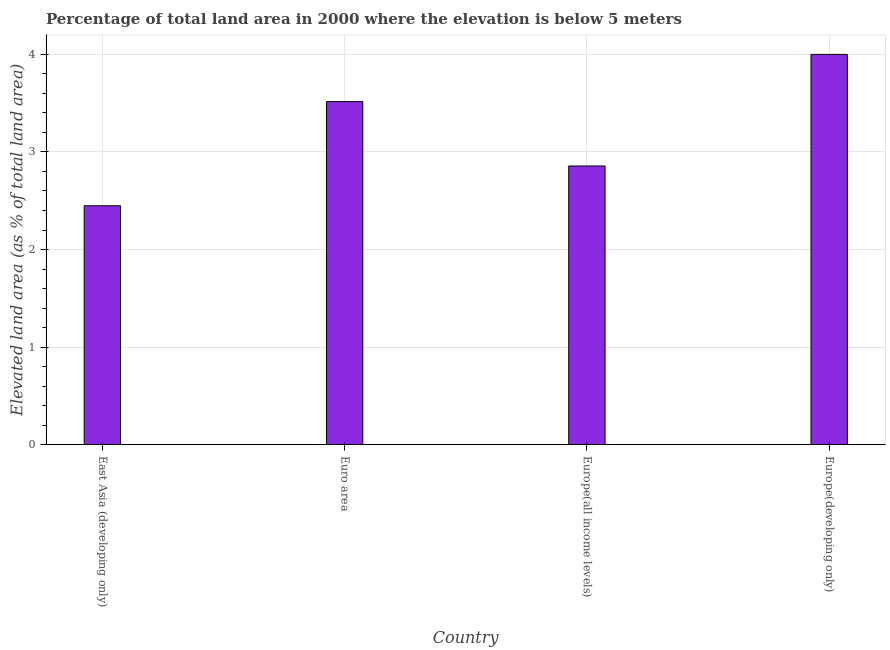Does the graph contain any zero values?
Your response must be concise. No. What is the title of the graph?
Ensure brevity in your answer.  Percentage of total land area in 2000 where the elevation is below 5 meters. What is the label or title of the X-axis?
Offer a very short reply. Country. What is the label or title of the Y-axis?
Offer a terse response. Elevated land area (as % of total land area). What is the total elevated land area in Euro area?
Offer a very short reply. 3.52. Across all countries, what is the maximum total elevated land area?
Make the answer very short. 4. Across all countries, what is the minimum total elevated land area?
Your answer should be very brief. 2.45. In which country was the total elevated land area maximum?
Ensure brevity in your answer.  Europe(developing only). In which country was the total elevated land area minimum?
Your answer should be compact. East Asia (developing only). What is the sum of the total elevated land area?
Give a very brief answer. 12.82. What is the difference between the total elevated land area in Euro area and Europe(all income levels)?
Your answer should be very brief. 0.66. What is the average total elevated land area per country?
Offer a very short reply. 3.21. What is the median total elevated land area?
Ensure brevity in your answer.  3.19. In how many countries, is the total elevated land area greater than 0.4 %?
Keep it short and to the point. 4. What is the ratio of the total elevated land area in Euro area to that in Europe(developing only)?
Your answer should be very brief. 0.88. Is the difference between the total elevated land area in Europe(all income levels) and Europe(developing only) greater than the difference between any two countries?
Your answer should be compact. No. What is the difference between the highest and the second highest total elevated land area?
Ensure brevity in your answer.  0.48. Is the sum of the total elevated land area in Euro area and Europe(all income levels) greater than the maximum total elevated land area across all countries?
Provide a succinct answer. Yes. What is the difference between the highest and the lowest total elevated land area?
Provide a succinct answer. 1.55. In how many countries, is the total elevated land area greater than the average total elevated land area taken over all countries?
Give a very brief answer. 2. How many bars are there?
Offer a terse response. 4. What is the difference between two consecutive major ticks on the Y-axis?
Make the answer very short. 1. What is the Elevated land area (as % of total land area) in East Asia (developing only)?
Your response must be concise. 2.45. What is the Elevated land area (as % of total land area) of Euro area?
Provide a succinct answer. 3.52. What is the Elevated land area (as % of total land area) in Europe(all income levels)?
Make the answer very short. 2.86. What is the Elevated land area (as % of total land area) of Europe(developing only)?
Offer a terse response. 4. What is the difference between the Elevated land area (as % of total land area) in East Asia (developing only) and Euro area?
Offer a terse response. -1.07. What is the difference between the Elevated land area (as % of total land area) in East Asia (developing only) and Europe(all income levels)?
Offer a very short reply. -0.41. What is the difference between the Elevated land area (as % of total land area) in East Asia (developing only) and Europe(developing only)?
Your answer should be very brief. -1.55. What is the difference between the Elevated land area (as % of total land area) in Euro area and Europe(all income levels)?
Offer a very short reply. 0.66. What is the difference between the Elevated land area (as % of total land area) in Euro area and Europe(developing only)?
Ensure brevity in your answer.  -0.48. What is the difference between the Elevated land area (as % of total land area) in Europe(all income levels) and Europe(developing only)?
Offer a terse response. -1.14. What is the ratio of the Elevated land area (as % of total land area) in East Asia (developing only) to that in Euro area?
Offer a very short reply. 0.7. What is the ratio of the Elevated land area (as % of total land area) in East Asia (developing only) to that in Europe(all income levels)?
Keep it short and to the point. 0.86. What is the ratio of the Elevated land area (as % of total land area) in East Asia (developing only) to that in Europe(developing only)?
Your answer should be compact. 0.61. What is the ratio of the Elevated land area (as % of total land area) in Euro area to that in Europe(all income levels)?
Offer a terse response. 1.23. What is the ratio of the Elevated land area (as % of total land area) in Euro area to that in Europe(developing only)?
Your answer should be compact. 0.88. What is the ratio of the Elevated land area (as % of total land area) in Europe(all income levels) to that in Europe(developing only)?
Your answer should be compact. 0.71. 